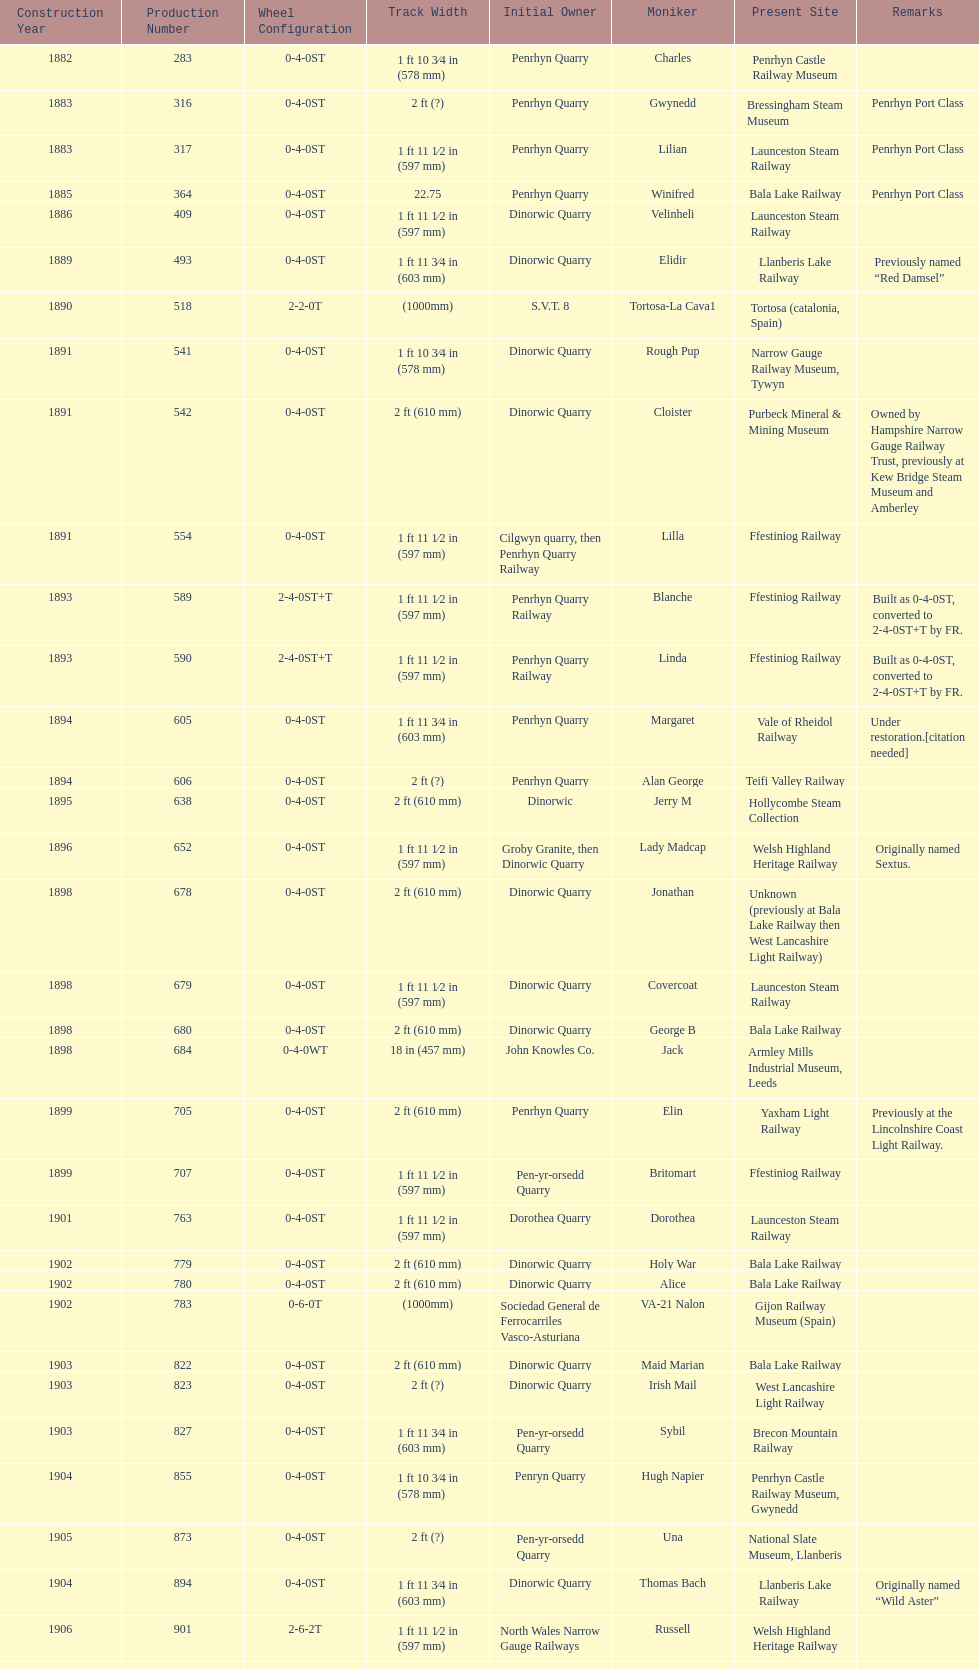What is the works number of the only item built in 1882? 283. 